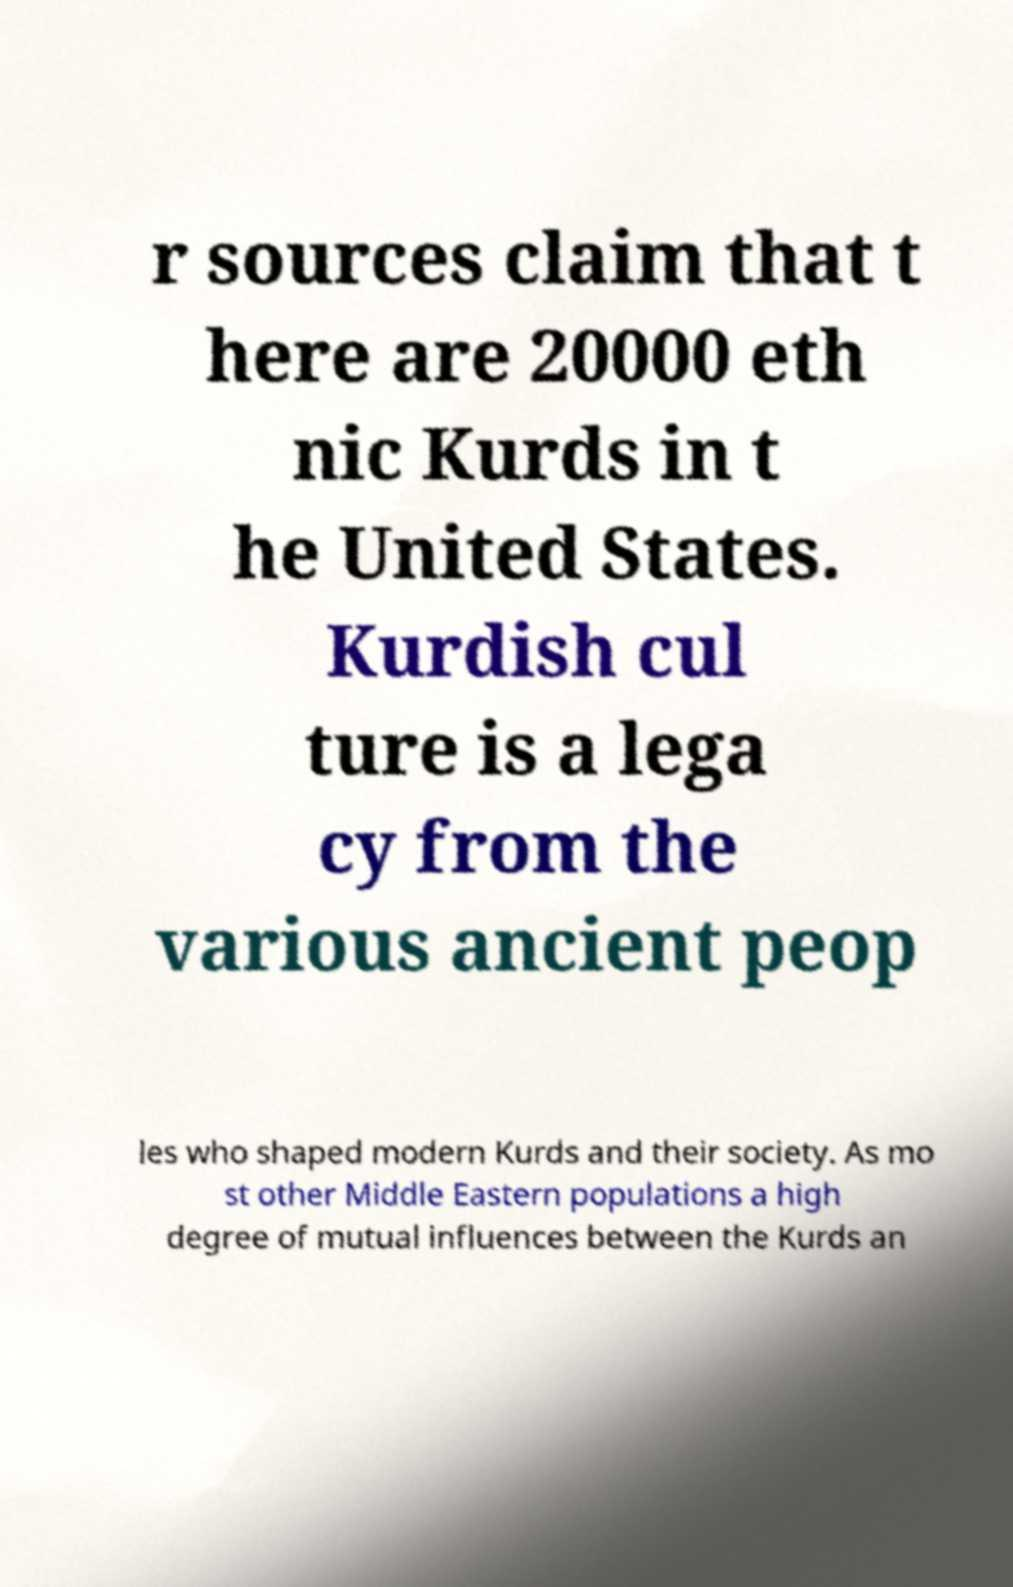Please read and relay the text visible in this image. What does it say? r sources claim that t here are 20000 eth nic Kurds in t he United States. Kurdish cul ture is a lega cy from the various ancient peop les who shaped modern Kurds and their society. As mo st other Middle Eastern populations a high degree of mutual influences between the Kurds an 